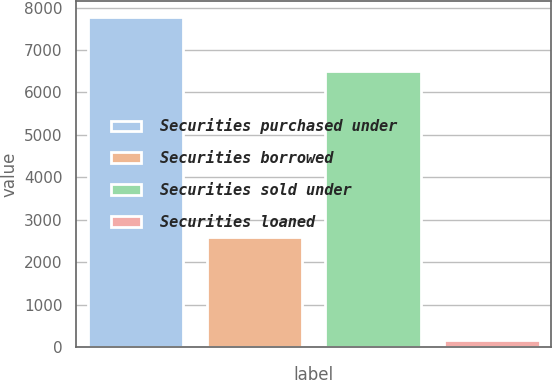Convert chart to OTSL. <chart><loc_0><loc_0><loc_500><loc_500><bar_chart><fcel>Securities purchased under<fcel>Securities borrowed<fcel>Securities sold under<fcel>Securities loaned<nl><fcel>7765<fcel>2591<fcel>6500<fcel>154<nl></chart> 